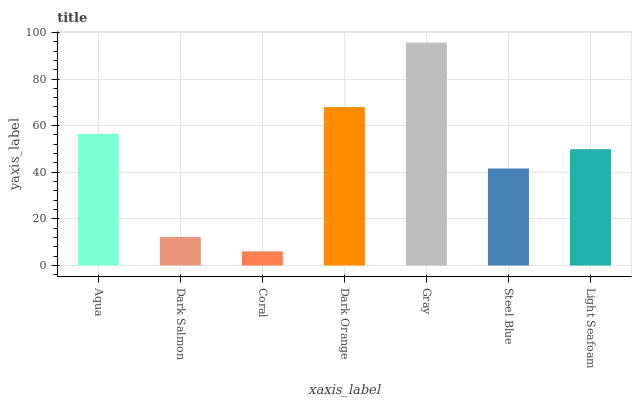Is Coral the minimum?
Answer yes or no. Yes. Is Gray the maximum?
Answer yes or no. Yes. Is Dark Salmon the minimum?
Answer yes or no. No. Is Dark Salmon the maximum?
Answer yes or no. No. Is Aqua greater than Dark Salmon?
Answer yes or no. Yes. Is Dark Salmon less than Aqua?
Answer yes or no. Yes. Is Dark Salmon greater than Aqua?
Answer yes or no. No. Is Aqua less than Dark Salmon?
Answer yes or no. No. Is Light Seafoam the high median?
Answer yes or no. Yes. Is Light Seafoam the low median?
Answer yes or no. Yes. Is Aqua the high median?
Answer yes or no. No. Is Aqua the low median?
Answer yes or no. No. 